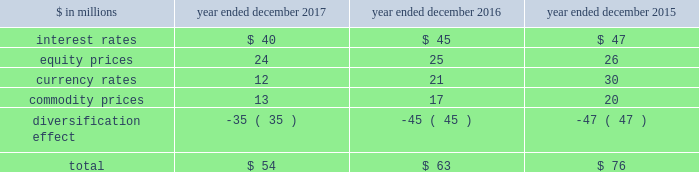The goldman sachs group , inc .
And subsidiaries management 2019s discussion and analysis the risk committee of the board and the risk governance committee ( through delegated authority from the firmwide risk committee ) approve market risk limits and sub-limits at firmwide , business and product levels , consistent with our risk appetite statement .
In addition , market risk management ( through delegated authority from the risk governance committee ) sets market risk limits and sub-limits at certain product and desk levels .
The purpose of the firmwide limits is to assist senior management in controlling our overall risk profile .
Sub-limits are set below the approved level of risk limits .
Sub-limits set the desired maximum amount of exposure that may be managed by any particular business on a day-to-day basis without additional levels of senior management approval , effectively leaving day-to-day decisions to individual desk managers and traders .
Accordingly , sub-limits are a management tool designed to ensure appropriate escalation rather than to establish maximum risk tolerance .
Sub-limits also distribute risk among various businesses in a manner that is consistent with their level of activity and client demand , taking into account the relative performance of each area .
Our market risk limits are monitored daily by market risk management , which is responsible for identifying and escalating , on a timely basis , instances where limits have been exceeded .
When a risk limit has been exceeded ( e.g. , due to positional changes or changes in market conditions , such as increased volatilities or changes in correlations ) , it is escalated to senior managers in market risk management and/or the appropriate risk committee .
Such instances are remediated by an inventory reduction and/or a temporary or permanent increase to the risk limit .
Model review and validation our var and stress testing models are regularly reviewed by market risk management and enhanced in order to incorporate changes in the composition of positions included in our market risk measures , as well as variations in market conditions .
Prior to implementing significant changes to our assumptions and/or models , model risk management performs model validations .
Significant changes to our var and stress testing models are reviewed with our chief risk officer and chief financial officer , and approved by the firmwide risk committee .
See 201cmodel risk management 201d for further information about the review and validation of these models .
Systems we have made a significant investment in technology to monitor market risk including : 2030 an independent calculation of var and stress measures ; 2030 risk measures calculated at individual position levels ; 2030 attribution of risk measures to individual risk factors of each position ; 2030 the ability to report many different views of the risk measures ( e.g. , by desk , business , product type or entity ) ; 2030 the ability to produce ad hoc analyses in a timely manner .
Metrics we analyze var at the firmwide level and a variety of more detailed levels , including by risk category , business , and region .
The tables below present average daily var and period-end var , as well as the high and low var for the period .
Diversification effect in the tables below represents the difference between total var and the sum of the vars for the four risk categories .
This effect arises because the four market risk categories are not perfectly correlated .
The table below presents average daily var by risk category. .
Our average daily var decreased to $ 54 million in 2017 from $ 63 million in 2016 , due to reductions across all risk categories , partially offset by a decrease in the diversification effect .
The overall decrease was primarily due to lower levels of volatility .
Our average daily var decreased to $ 63 million in 2016 from $ 76 million in 2015 , due to reductions across all risk categories , partially offset by a decrease in the diversification effect .
The overall decrease was primarily due to reduced exposures .
Goldman sachs 2017 form 10-k 91 .
In millions for 2017 , was the average daily var by risk category for impact of interest rates greater than equity prices? 
Computations: (40 > 24)
Answer: yes. 